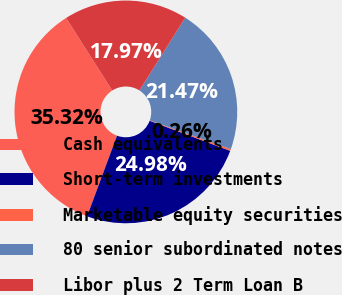Convert chart. <chart><loc_0><loc_0><loc_500><loc_500><pie_chart><fcel>Cash equivalents<fcel>Short-term investments<fcel>Marketable equity securities<fcel>80 senior subordinated notes<fcel>Libor plus 2 Term Loan B<nl><fcel>35.32%<fcel>24.98%<fcel>0.26%<fcel>21.47%<fcel>17.97%<nl></chart> 